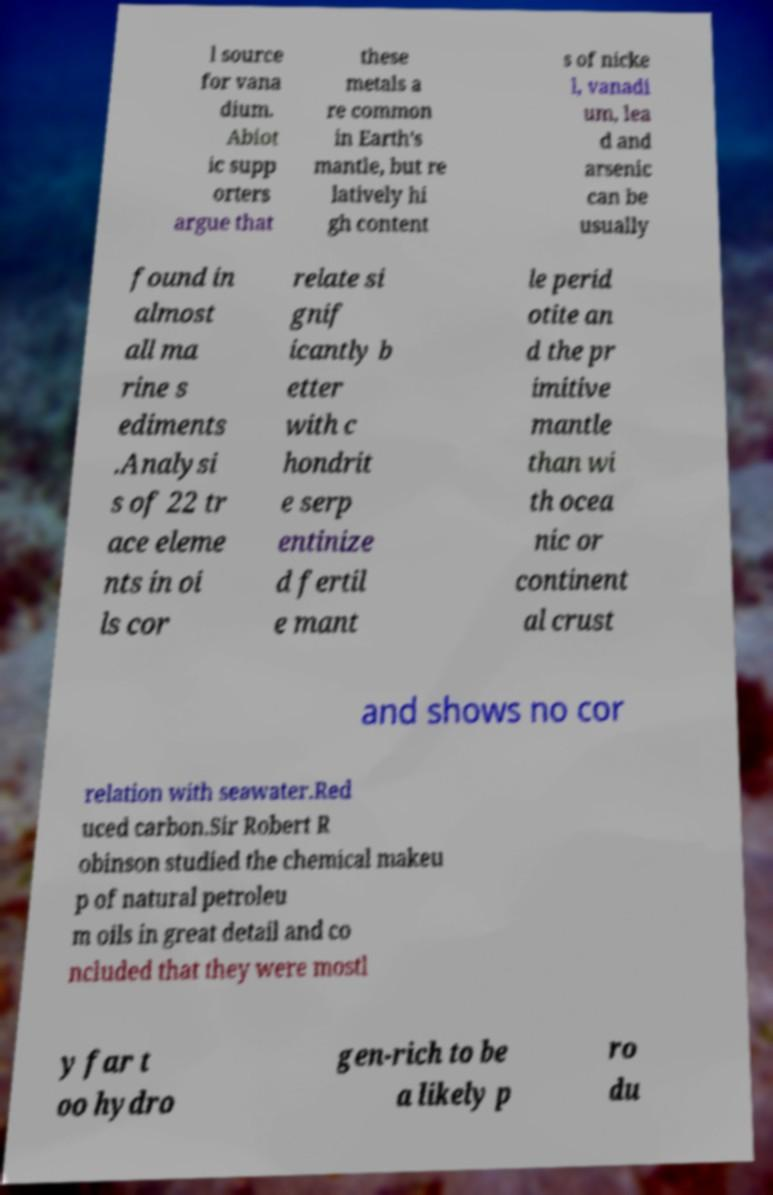Can you read and provide the text displayed in the image?This photo seems to have some interesting text. Can you extract and type it out for me? l source for vana dium. Abiot ic supp orters argue that these metals a re common in Earth's mantle, but re latively hi gh content s of nicke l, vanadi um, lea d and arsenic can be usually found in almost all ma rine s ediments .Analysi s of 22 tr ace eleme nts in oi ls cor relate si gnif icantly b etter with c hondrit e serp entinize d fertil e mant le perid otite an d the pr imitive mantle than wi th ocea nic or continent al crust and shows no cor relation with seawater.Red uced carbon.Sir Robert R obinson studied the chemical makeu p of natural petroleu m oils in great detail and co ncluded that they were mostl y far t oo hydro gen-rich to be a likely p ro du 